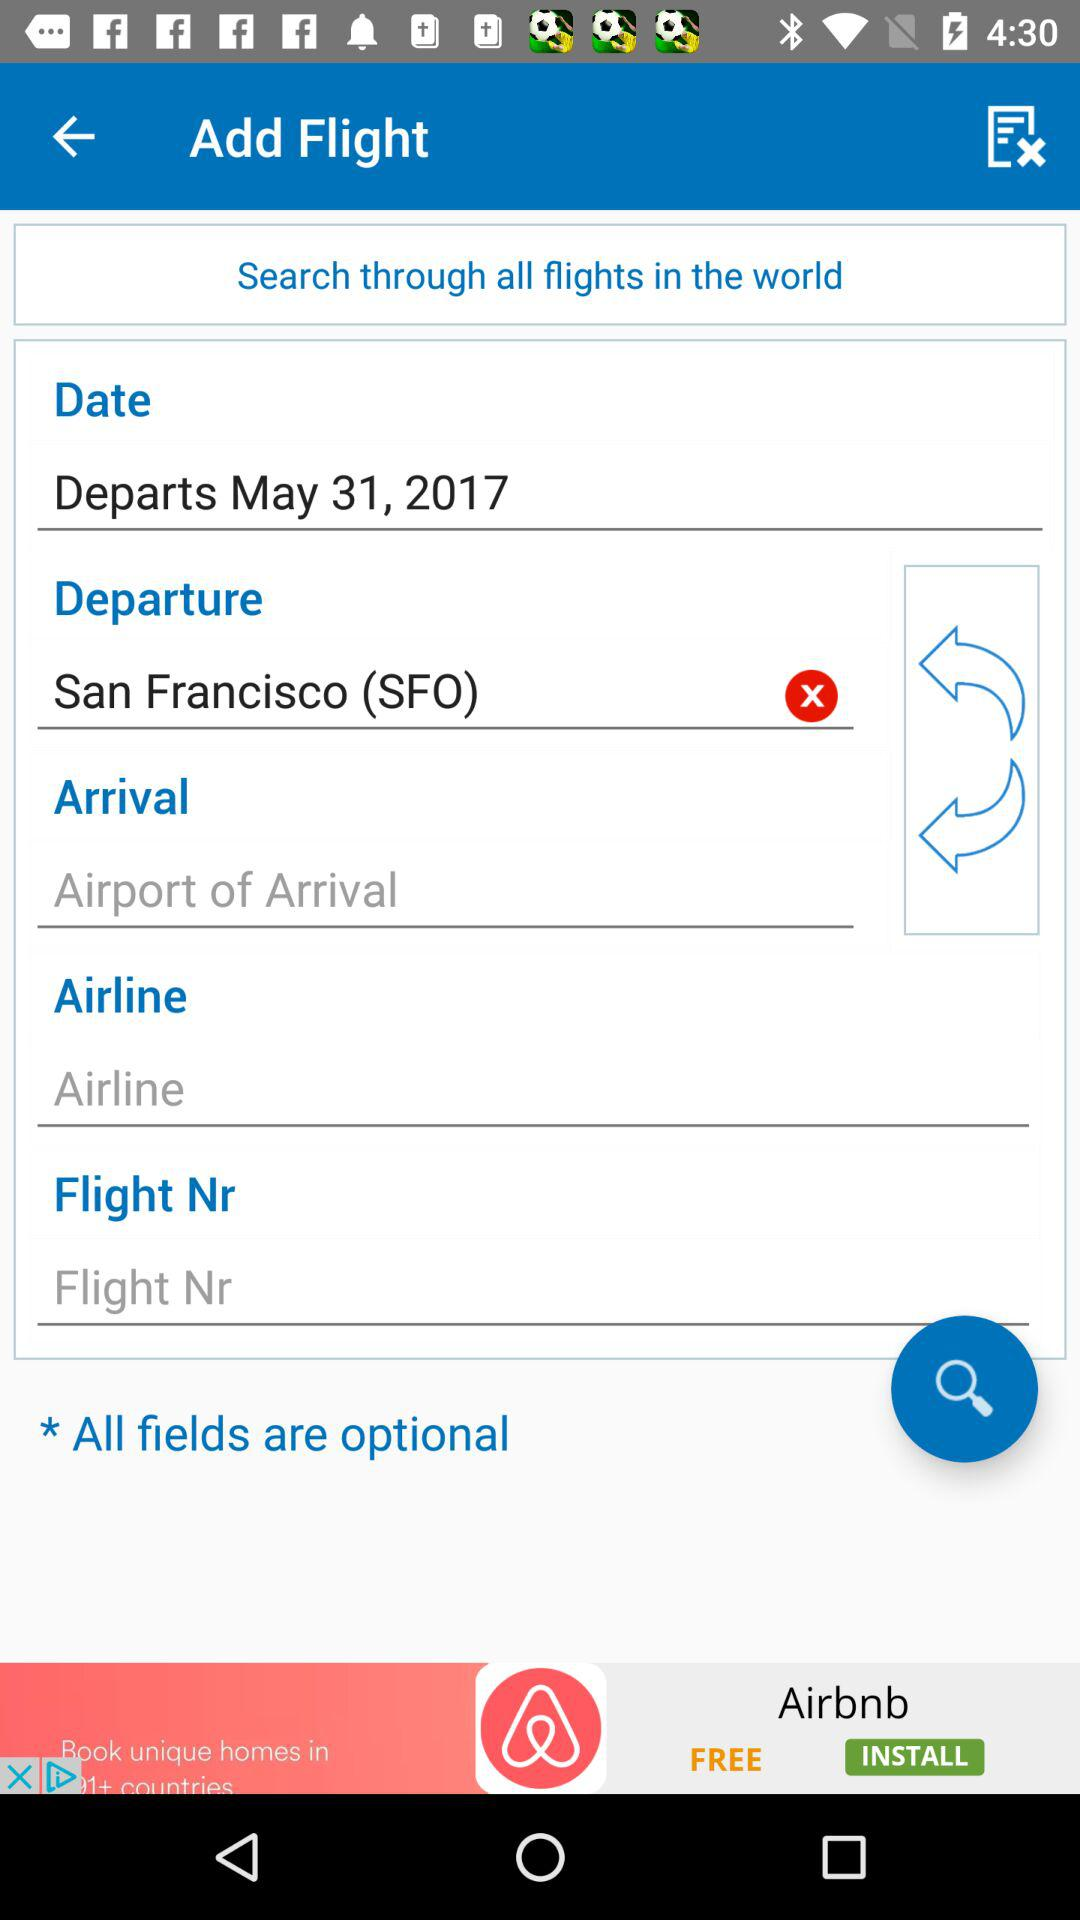How many of the text inputs have an airline value?
Answer the question using a single word or phrase. 1 